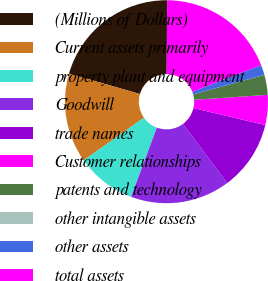<chart> <loc_0><loc_0><loc_500><loc_500><pie_chart><fcel>(Millions of Dollars)<fcel>Current assets primarily<fcel>property plant and equipment<fcel>Goodwill<fcel>trade names<fcel>Customer relationships<fcel>patents and technology<fcel>other intangible assets<fcel>other assets<fcel>total assets<nl><fcel>20.62%<fcel>14.28%<fcel>9.52%<fcel>15.86%<fcel>11.11%<fcel>4.77%<fcel>3.18%<fcel>0.01%<fcel>1.6%<fcel>19.03%<nl></chart> 